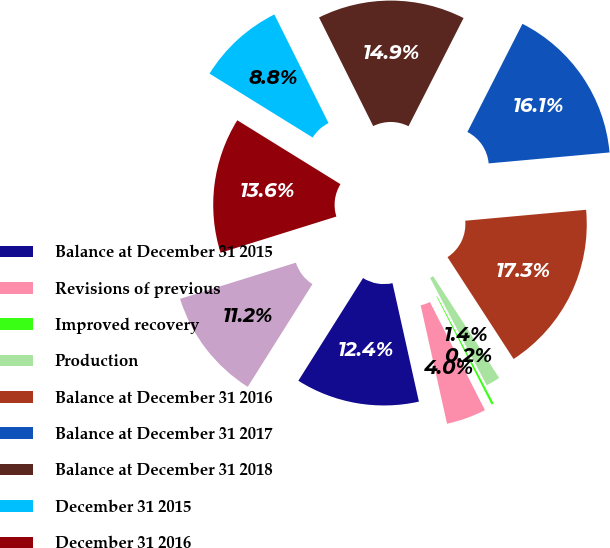<chart> <loc_0><loc_0><loc_500><loc_500><pie_chart><fcel>Balance at December 31 2015<fcel>Revisions of previous<fcel>Improved recovery<fcel>Production<fcel>Balance at December 31 2016<fcel>Balance at December 31 2017<fcel>Balance at December 31 2018<fcel>December 31 2015<fcel>December 31 2016<fcel>December 31 2017<nl><fcel>12.44%<fcel>4.0%<fcel>0.23%<fcel>1.44%<fcel>17.28%<fcel>16.07%<fcel>14.86%<fcel>8.81%<fcel>13.65%<fcel>11.23%<nl></chart> 